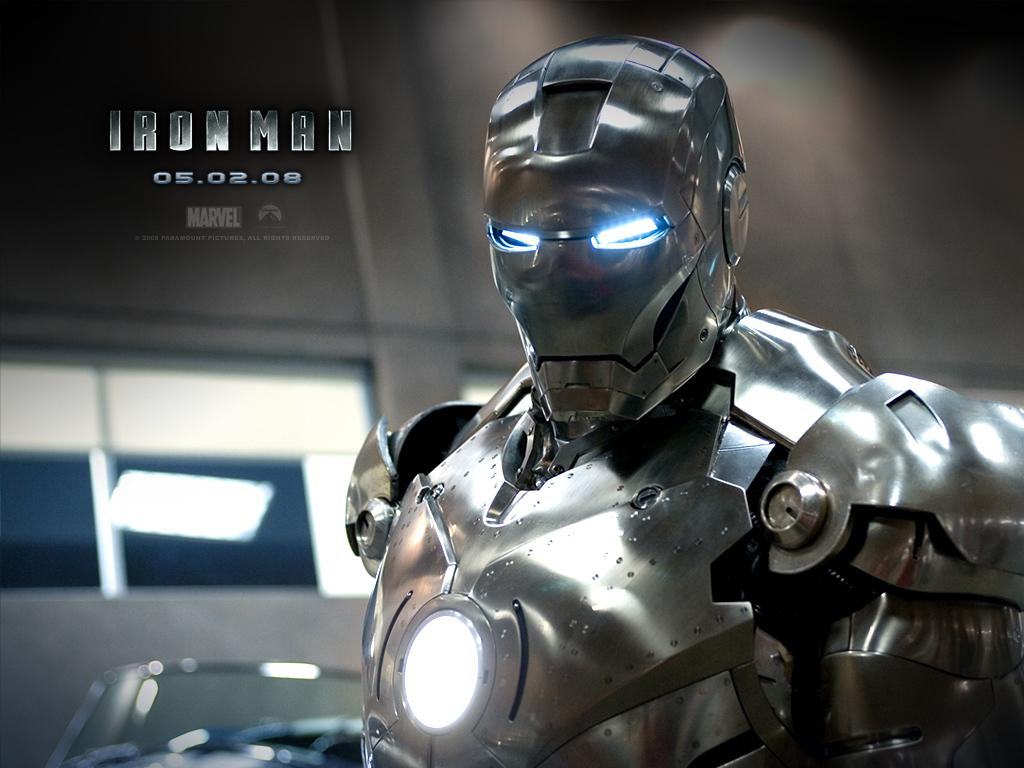What is featured on the poster in the image? There is a poster with an image and text in the image. What can be seen in the background of the image? There is a wall with a window in the background. What is located on the right side of the image? There is a robot on the right side of the image. What type of brush is the robot using to paint the wall in the image? There is no brush or painting activity present in the image; it features a robot on the right side. How many wheels does the robot have in the image? The image does not show the robot's wheels, so it cannot be determined from the image. 